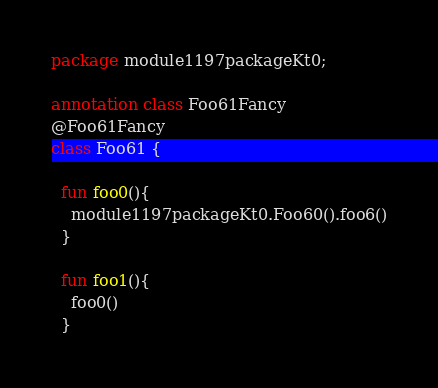Convert code to text. <code><loc_0><loc_0><loc_500><loc_500><_Kotlin_>package module1197packageKt0;

annotation class Foo61Fancy
@Foo61Fancy
class Foo61 {

  fun foo0(){
    module1197packageKt0.Foo60().foo6()
  }

  fun foo1(){
    foo0()
  }
</code> 